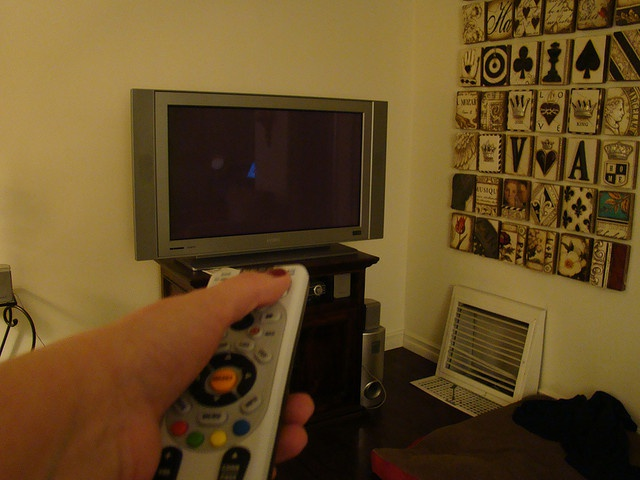Describe the objects in this image and their specific colors. I can see tv in tan, black, and olive tones, people in tan, maroon, brown, and black tones, and remote in tan, black, olive, and maroon tones in this image. 